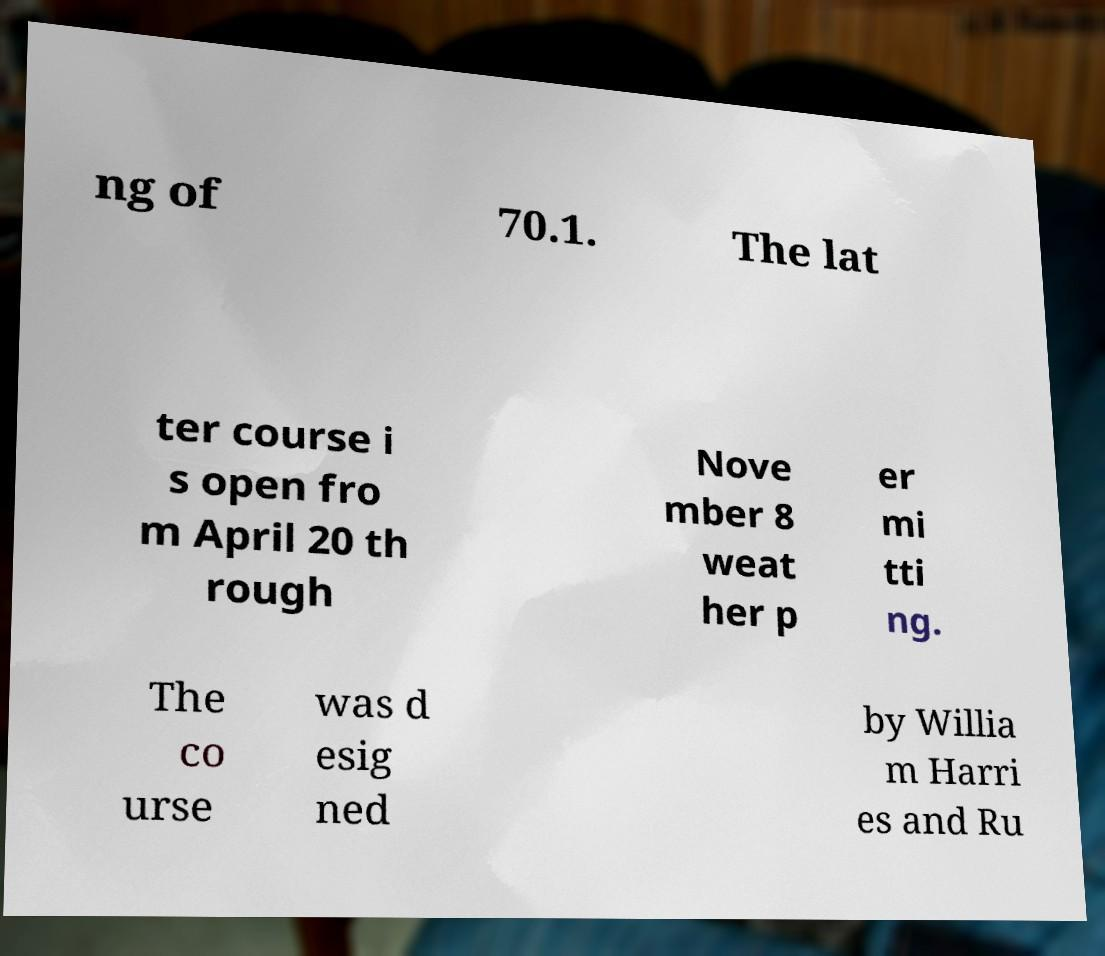For documentation purposes, I need the text within this image transcribed. Could you provide that? ng of 70.1. The lat ter course i s open fro m April 20 th rough Nove mber 8 weat her p er mi tti ng. The co urse was d esig ned by Willia m Harri es and Ru 